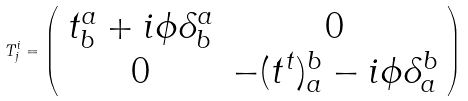<formula> <loc_0><loc_0><loc_500><loc_500>T _ { j } ^ { i } = \left ( \begin{array} { c c } t ^ { a } _ { b } + i \phi \delta ^ { a } _ { b } & 0 \\ 0 & - ( t ^ { t } ) _ { a } ^ { b } - i \phi \delta _ { a } ^ { b } \end{array} \right )</formula> 